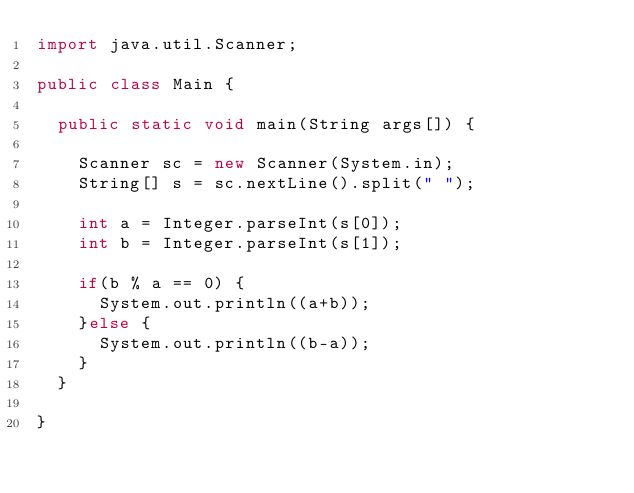Convert code to text. <code><loc_0><loc_0><loc_500><loc_500><_Java_>import java.util.Scanner;

public class Main {

	public static void main(String args[]) {

		Scanner sc = new Scanner(System.in);
		String[] s = sc.nextLine().split(" ");

		int a = Integer.parseInt(s[0]);
		int b = Integer.parseInt(s[1]);

		if(b % a == 0) {
			System.out.println((a+b));
		}else {
			System.out.println((b-a));
		}
	}

}</code> 